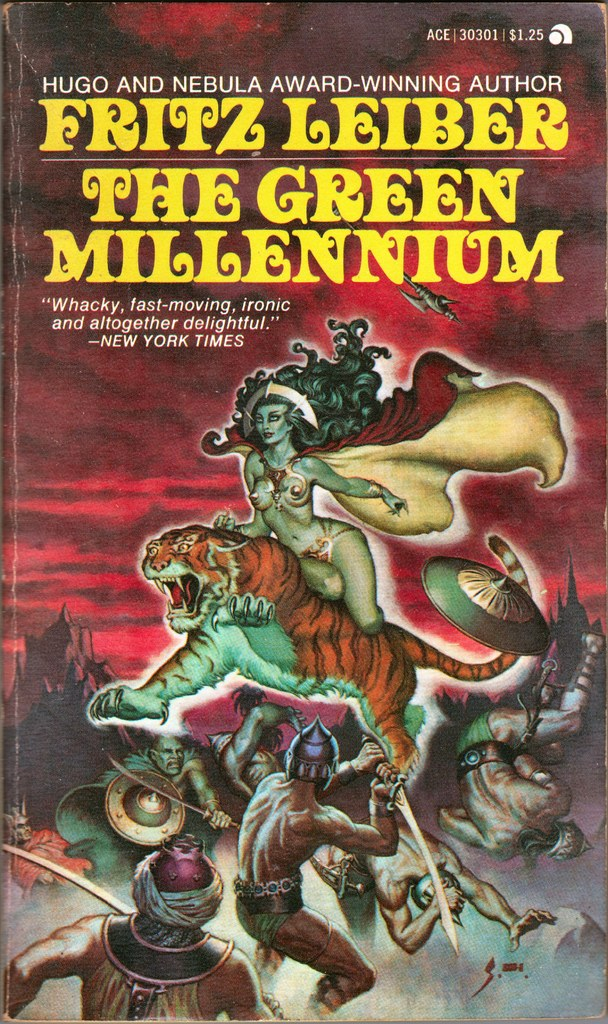Can you describe the main features of this image for me? The image displays the book cover for 'The Green Millennium' by Fritz Leiber, noted for winning both Hugo and Nebula awards. The cover features a vibrant and action-packed illustration depicting a fantastical scene where a woman rides a formidable tiger, soaring above a chaotic battle involving warriors. These figures are set against a vividly colored backdrop, suggesting a mystical or apocalyptic setting. The cover also features prominent typography with the author’s name and the book title, along with a glowing recommendation from the New York Times, describing the book as 'Whacky, fast-moving, ironic and altogether delightful.' The price is marked at $1.25, indicating a vintage or collectible edition by Ace Books. 